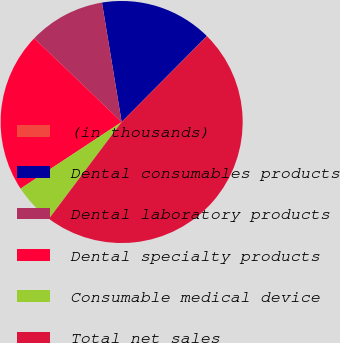Convert chart. <chart><loc_0><loc_0><loc_500><loc_500><pie_chart><fcel>(in thousands)<fcel>Dental consumables products<fcel>Dental laboratory products<fcel>Dental specialty products<fcel>Consumable medical device<fcel>Total net sales<nl><fcel>0.03%<fcel>15.03%<fcel>10.25%<fcel>21.43%<fcel>5.47%<fcel>47.79%<nl></chart> 